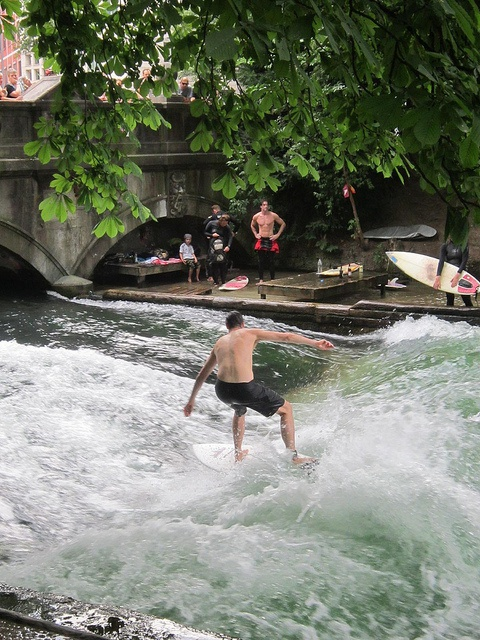Describe the objects in this image and their specific colors. I can see people in darkgreen, tan, black, gray, and darkgray tones, bench in darkgreen, black, and gray tones, surfboard in darkgreen, ivory, tan, lightpink, and gray tones, people in darkgreen, black, brown, salmon, and maroon tones, and people in darkgreen, black, gray, maroon, and darkgray tones in this image. 